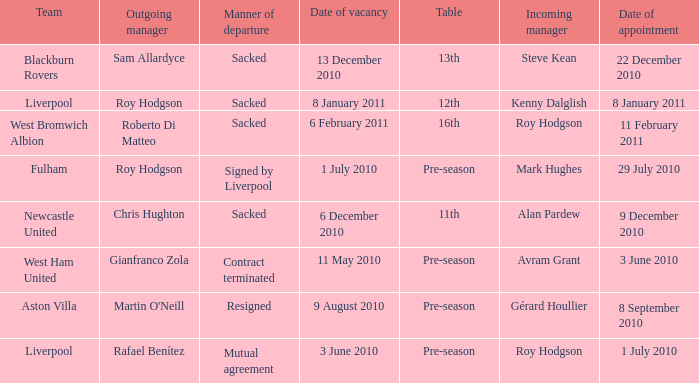What is the table for the team Blackburn Rovers? 13th. 